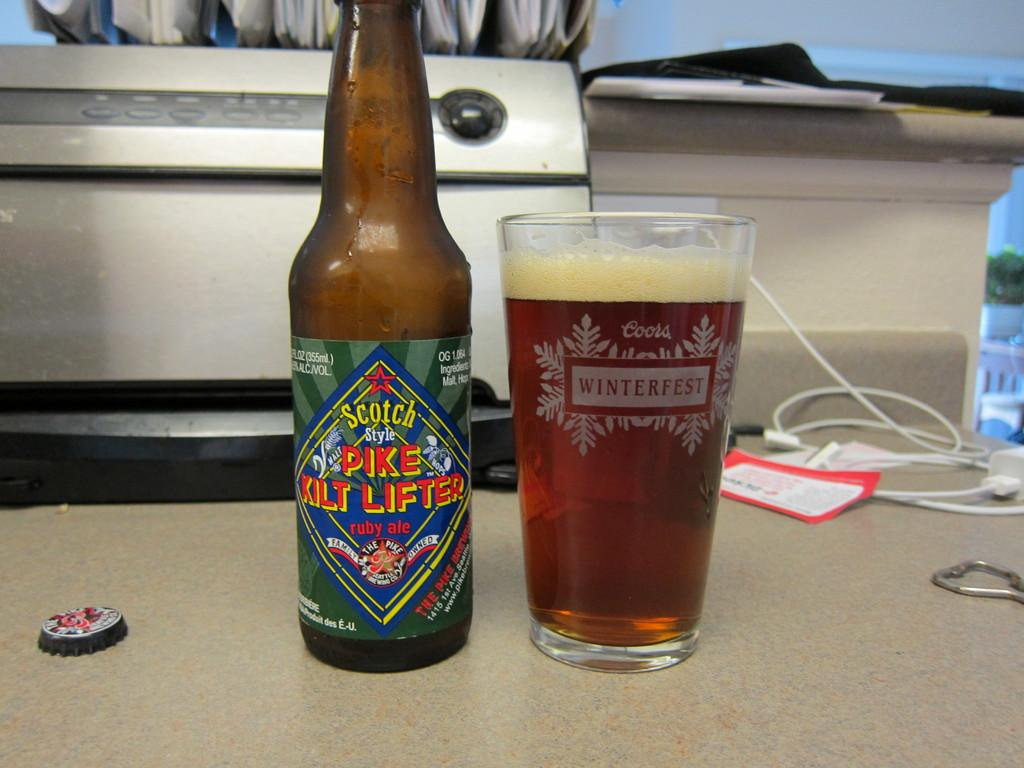What type of beverage is in the bottle in the image? There is a bottle of scotch in the image. What is the glass used for in the image? The glass is likely used for drinking the scotch. Where are the bottle and glass located in the image? Both the bottle and glass are on a table. What can be seen in the background of the image? There is a machine in the background of the image. What item is to the right of the table in the image? There is a mobile charger to the right of the table. What type of oatmeal is being prepared in the image? There is no oatmeal present in the image; it features a bottle of scotch, a glass, and a table setting. How many people are seen kissing in the image? There are no people kissing in the image; it focuses on a bottle of scotch, a glass, and a table setting. 